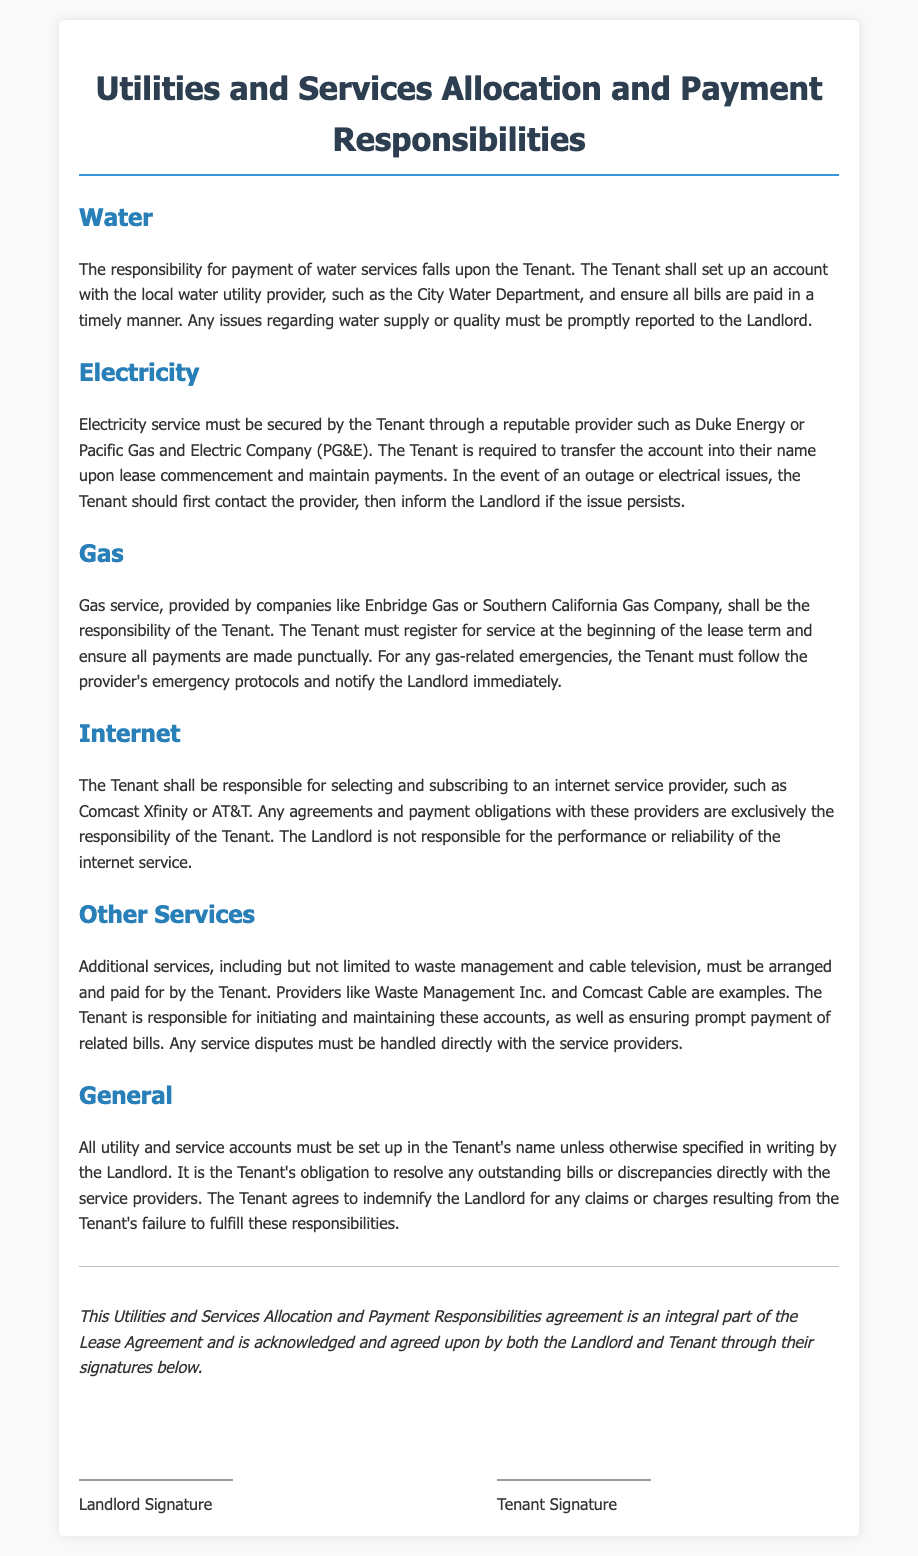What is the Tenant responsible for regarding water services? The Tenant is responsible for payment of water services and must set up an account.
Answer: Payment of water services Which utility service must be secured by the Tenant? The document states that electricity service must be secured by the Tenant.
Answer: Electricity Who should the Tenant contact first in case of an electricity outage? The document specifies that the Tenant should first contact the electricity provider in the event of an outage.
Answer: The provider What type of services must the Tenant arrange and pay for? The document mentions that services like waste management and cable television must be arranged by the Tenant.
Answer: Waste management and cable television What is the Tenant required to do at the beginning of the lease term for gas service? The Tenant must register for gas service at the beginning of the lease term.
Answer: Register for service In case of discrepancies with service providers, who is obligated to resolve issues? The Tenant is obligated to resolve any outstanding bills or discrepancies with the service providers.
Answer: The Tenant What must all utility accounts be set up in? The document states all utility accounts must be set up in the Tenant's name.
Answer: Tenant's name What does the Tenant need to do if there are any issues regarding water supply? The Tenant must promptly report any issues regarding water supply to the Landlord.
Answer: Report to the Landlord Is the Landlord responsible for the performance of the internet service? The document specifies that the Landlord is not responsible for the performance or reliability of the internet service.
Answer: No 